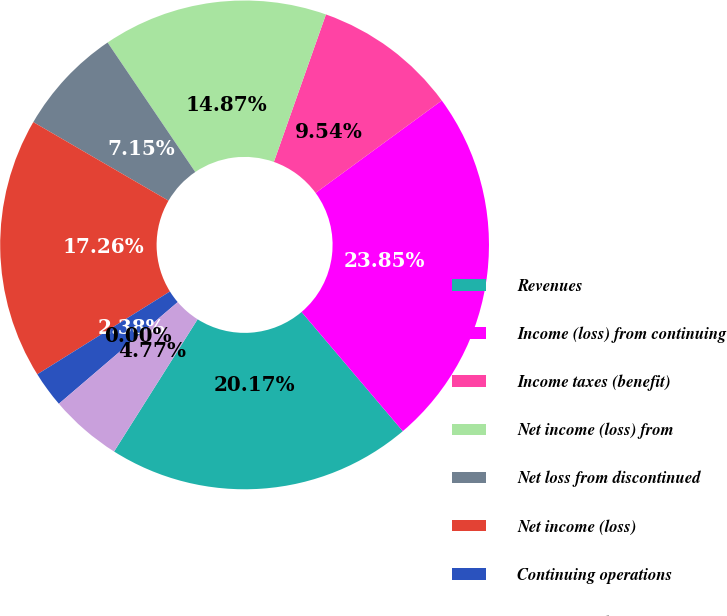<chart> <loc_0><loc_0><loc_500><loc_500><pie_chart><fcel>Revenues<fcel>Income (loss) from continuing<fcel>Income taxes (benefit)<fcel>Net income (loss) from<fcel>Net loss from discontinued<fcel>Net income (loss)<fcel>Continuing operations<fcel>Discontinued operations<fcel>Consolidated<nl><fcel>20.17%<fcel>23.85%<fcel>9.54%<fcel>14.87%<fcel>7.15%<fcel>17.26%<fcel>2.38%<fcel>0.0%<fcel>4.77%<nl></chart> 